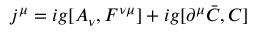Convert formula to latex. <formula><loc_0><loc_0><loc_500><loc_500>j ^ { \mu } = i g [ A _ { \nu } , F ^ { \nu \mu } ] + i g [ \partial ^ { \mu } \bar { C } , C ]</formula> 